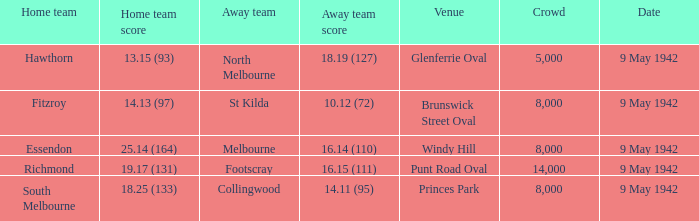How large was the crowd with a home team score of 18.25 (133)? 8000.0. 